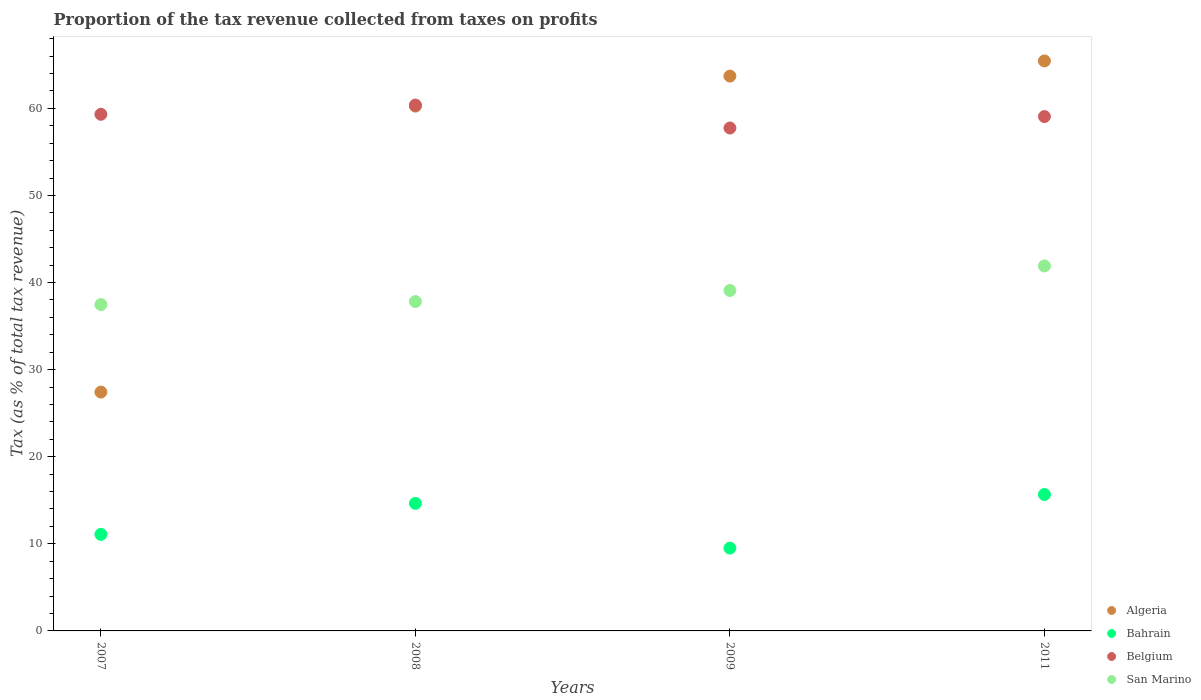How many different coloured dotlines are there?
Provide a short and direct response. 4. What is the proportion of the tax revenue collected in San Marino in 2008?
Offer a very short reply. 37.82. Across all years, what is the maximum proportion of the tax revenue collected in Algeria?
Offer a terse response. 65.45. Across all years, what is the minimum proportion of the tax revenue collected in San Marino?
Give a very brief answer. 37.47. In which year was the proportion of the tax revenue collected in Algeria maximum?
Give a very brief answer. 2011. What is the total proportion of the tax revenue collected in Bahrain in the graph?
Your answer should be very brief. 50.9. What is the difference between the proportion of the tax revenue collected in Belgium in 2008 and that in 2009?
Offer a very short reply. 2.63. What is the difference between the proportion of the tax revenue collected in San Marino in 2008 and the proportion of the tax revenue collected in Belgium in 2007?
Make the answer very short. -21.5. What is the average proportion of the tax revenue collected in Algeria per year?
Provide a short and direct response. 54.21. In the year 2008, what is the difference between the proportion of the tax revenue collected in San Marino and proportion of the tax revenue collected in Belgium?
Offer a terse response. -22.56. What is the ratio of the proportion of the tax revenue collected in Algeria in 2009 to that in 2011?
Provide a succinct answer. 0.97. What is the difference between the highest and the second highest proportion of the tax revenue collected in San Marino?
Give a very brief answer. 2.82. What is the difference between the highest and the lowest proportion of the tax revenue collected in Bahrain?
Provide a succinct answer. 6.15. Is the sum of the proportion of the tax revenue collected in Algeria in 2007 and 2009 greater than the maximum proportion of the tax revenue collected in Belgium across all years?
Provide a succinct answer. Yes. Is it the case that in every year, the sum of the proportion of the tax revenue collected in Belgium and proportion of the tax revenue collected in San Marino  is greater than the sum of proportion of the tax revenue collected in Bahrain and proportion of the tax revenue collected in Algeria?
Provide a succinct answer. No. Does the proportion of the tax revenue collected in Belgium monotonically increase over the years?
Provide a short and direct response. No. Is the proportion of the tax revenue collected in San Marino strictly greater than the proportion of the tax revenue collected in Bahrain over the years?
Ensure brevity in your answer.  Yes. Is the proportion of the tax revenue collected in Bahrain strictly less than the proportion of the tax revenue collected in Belgium over the years?
Your answer should be very brief. Yes. How many dotlines are there?
Keep it short and to the point. 4. How many years are there in the graph?
Give a very brief answer. 4. What is the difference between two consecutive major ticks on the Y-axis?
Ensure brevity in your answer.  10. Where does the legend appear in the graph?
Your answer should be very brief. Bottom right. How are the legend labels stacked?
Ensure brevity in your answer.  Vertical. What is the title of the graph?
Offer a terse response. Proportion of the tax revenue collected from taxes on profits. Does "Nicaragua" appear as one of the legend labels in the graph?
Offer a very short reply. No. What is the label or title of the X-axis?
Your answer should be very brief. Years. What is the label or title of the Y-axis?
Your response must be concise. Tax (as % of total tax revenue). What is the Tax (as % of total tax revenue) of Algeria in 2007?
Your answer should be compact. 27.42. What is the Tax (as % of total tax revenue) in Bahrain in 2007?
Your response must be concise. 11.08. What is the Tax (as % of total tax revenue) of Belgium in 2007?
Keep it short and to the point. 59.32. What is the Tax (as % of total tax revenue) of San Marino in 2007?
Make the answer very short. 37.47. What is the Tax (as % of total tax revenue) in Algeria in 2008?
Give a very brief answer. 60.26. What is the Tax (as % of total tax revenue) of Bahrain in 2008?
Ensure brevity in your answer.  14.65. What is the Tax (as % of total tax revenue) in Belgium in 2008?
Your response must be concise. 60.38. What is the Tax (as % of total tax revenue) of San Marino in 2008?
Make the answer very short. 37.82. What is the Tax (as % of total tax revenue) of Algeria in 2009?
Ensure brevity in your answer.  63.71. What is the Tax (as % of total tax revenue) of Bahrain in 2009?
Your answer should be very brief. 9.51. What is the Tax (as % of total tax revenue) of Belgium in 2009?
Your answer should be very brief. 57.75. What is the Tax (as % of total tax revenue) of San Marino in 2009?
Give a very brief answer. 39.09. What is the Tax (as % of total tax revenue) in Algeria in 2011?
Provide a succinct answer. 65.45. What is the Tax (as % of total tax revenue) in Bahrain in 2011?
Your answer should be compact. 15.66. What is the Tax (as % of total tax revenue) in Belgium in 2011?
Ensure brevity in your answer.  59.06. What is the Tax (as % of total tax revenue) of San Marino in 2011?
Your answer should be compact. 41.91. Across all years, what is the maximum Tax (as % of total tax revenue) in Algeria?
Provide a succinct answer. 65.45. Across all years, what is the maximum Tax (as % of total tax revenue) in Bahrain?
Your answer should be compact. 15.66. Across all years, what is the maximum Tax (as % of total tax revenue) of Belgium?
Your answer should be very brief. 60.38. Across all years, what is the maximum Tax (as % of total tax revenue) of San Marino?
Give a very brief answer. 41.91. Across all years, what is the minimum Tax (as % of total tax revenue) in Algeria?
Your answer should be compact. 27.42. Across all years, what is the minimum Tax (as % of total tax revenue) of Bahrain?
Provide a short and direct response. 9.51. Across all years, what is the minimum Tax (as % of total tax revenue) in Belgium?
Ensure brevity in your answer.  57.75. Across all years, what is the minimum Tax (as % of total tax revenue) in San Marino?
Offer a very short reply. 37.47. What is the total Tax (as % of total tax revenue) of Algeria in the graph?
Offer a terse response. 216.83. What is the total Tax (as % of total tax revenue) of Bahrain in the graph?
Provide a succinct answer. 50.9. What is the total Tax (as % of total tax revenue) in Belgium in the graph?
Offer a very short reply. 236.51. What is the total Tax (as % of total tax revenue) in San Marino in the graph?
Give a very brief answer. 156.29. What is the difference between the Tax (as % of total tax revenue) of Algeria in 2007 and that in 2008?
Keep it short and to the point. -32.84. What is the difference between the Tax (as % of total tax revenue) of Bahrain in 2007 and that in 2008?
Offer a terse response. -3.56. What is the difference between the Tax (as % of total tax revenue) in Belgium in 2007 and that in 2008?
Keep it short and to the point. -1.06. What is the difference between the Tax (as % of total tax revenue) in San Marino in 2007 and that in 2008?
Your response must be concise. -0.35. What is the difference between the Tax (as % of total tax revenue) in Algeria in 2007 and that in 2009?
Offer a terse response. -36.28. What is the difference between the Tax (as % of total tax revenue) in Bahrain in 2007 and that in 2009?
Keep it short and to the point. 1.57. What is the difference between the Tax (as % of total tax revenue) in Belgium in 2007 and that in 2009?
Make the answer very short. 1.57. What is the difference between the Tax (as % of total tax revenue) in San Marino in 2007 and that in 2009?
Your answer should be very brief. -1.62. What is the difference between the Tax (as % of total tax revenue) in Algeria in 2007 and that in 2011?
Your answer should be very brief. -38.02. What is the difference between the Tax (as % of total tax revenue) in Bahrain in 2007 and that in 2011?
Provide a short and direct response. -4.58. What is the difference between the Tax (as % of total tax revenue) of Belgium in 2007 and that in 2011?
Ensure brevity in your answer.  0.26. What is the difference between the Tax (as % of total tax revenue) of San Marino in 2007 and that in 2011?
Offer a very short reply. -4.43. What is the difference between the Tax (as % of total tax revenue) in Algeria in 2008 and that in 2009?
Your answer should be compact. -3.45. What is the difference between the Tax (as % of total tax revenue) of Bahrain in 2008 and that in 2009?
Ensure brevity in your answer.  5.14. What is the difference between the Tax (as % of total tax revenue) in Belgium in 2008 and that in 2009?
Your answer should be compact. 2.63. What is the difference between the Tax (as % of total tax revenue) in San Marino in 2008 and that in 2009?
Make the answer very short. -1.27. What is the difference between the Tax (as % of total tax revenue) of Algeria in 2008 and that in 2011?
Ensure brevity in your answer.  -5.19. What is the difference between the Tax (as % of total tax revenue) in Bahrain in 2008 and that in 2011?
Make the answer very short. -1.01. What is the difference between the Tax (as % of total tax revenue) in Belgium in 2008 and that in 2011?
Offer a very short reply. 1.32. What is the difference between the Tax (as % of total tax revenue) of San Marino in 2008 and that in 2011?
Keep it short and to the point. -4.09. What is the difference between the Tax (as % of total tax revenue) of Algeria in 2009 and that in 2011?
Provide a succinct answer. -1.74. What is the difference between the Tax (as % of total tax revenue) of Bahrain in 2009 and that in 2011?
Keep it short and to the point. -6.15. What is the difference between the Tax (as % of total tax revenue) of Belgium in 2009 and that in 2011?
Your answer should be very brief. -1.32. What is the difference between the Tax (as % of total tax revenue) of San Marino in 2009 and that in 2011?
Give a very brief answer. -2.82. What is the difference between the Tax (as % of total tax revenue) in Algeria in 2007 and the Tax (as % of total tax revenue) in Bahrain in 2008?
Make the answer very short. 12.77. What is the difference between the Tax (as % of total tax revenue) in Algeria in 2007 and the Tax (as % of total tax revenue) in Belgium in 2008?
Ensure brevity in your answer.  -32.96. What is the difference between the Tax (as % of total tax revenue) in Algeria in 2007 and the Tax (as % of total tax revenue) in San Marino in 2008?
Provide a short and direct response. -10.4. What is the difference between the Tax (as % of total tax revenue) in Bahrain in 2007 and the Tax (as % of total tax revenue) in Belgium in 2008?
Provide a short and direct response. -49.29. What is the difference between the Tax (as % of total tax revenue) in Bahrain in 2007 and the Tax (as % of total tax revenue) in San Marino in 2008?
Give a very brief answer. -26.74. What is the difference between the Tax (as % of total tax revenue) in Belgium in 2007 and the Tax (as % of total tax revenue) in San Marino in 2008?
Ensure brevity in your answer.  21.5. What is the difference between the Tax (as % of total tax revenue) of Algeria in 2007 and the Tax (as % of total tax revenue) of Bahrain in 2009?
Offer a very short reply. 17.91. What is the difference between the Tax (as % of total tax revenue) of Algeria in 2007 and the Tax (as % of total tax revenue) of Belgium in 2009?
Provide a short and direct response. -30.32. What is the difference between the Tax (as % of total tax revenue) in Algeria in 2007 and the Tax (as % of total tax revenue) in San Marino in 2009?
Provide a short and direct response. -11.67. What is the difference between the Tax (as % of total tax revenue) of Bahrain in 2007 and the Tax (as % of total tax revenue) of Belgium in 2009?
Your answer should be very brief. -46.66. What is the difference between the Tax (as % of total tax revenue) in Bahrain in 2007 and the Tax (as % of total tax revenue) in San Marino in 2009?
Provide a short and direct response. -28.01. What is the difference between the Tax (as % of total tax revenue) in Belgium in 2007 and the Tax (as % of total tax revenue) in San Marino in 2009?
Your response must be concise. 20.23. What is the difference between the Tax (as % of total tax revenue) of Algeria in 2007 and the Tax (as % of total tax revenue) of Bahrain in 2011?
Offer a very short reply. 11.76. What is the difference between the Tax (as % of total tax revenue) in Algeria in 2007 and the Tax (as % of total tax revenue) in Belgium in 2011?
Offer a terse response. -31.64. What is the difference between the Tax (as % of total tax revenue) of Algeria in 2007 and the Tax (as % of total tax revenue) of San Marino in 2011?
Give a very brief answer. -14.48. What is the difference between the Tax (as % of total tax revenue) of Bahrain in 2007 and the Tax (as % of total tax revenue) of Belgium in 2011?
Your response must be concise. -47.98. What is the difference between the Tax (as % of total tax revenue) in Bahrain in 2007 and the Tax (as % of total tax revenue) in San Marino in 2011?
Offer a very short reply. -30.82. What is the difference between the Tax (as % of total tax revenue) in Belgium in 2007 and the Tax (as % of total tax revenue) in San Marino in 2011?
Keep it short and to the point. 17.41. What is the difference between the Tax (as % of total tax revenue) in Algeria in 2008 and the Tax (as % of total tax revenue) in Bahrain in 2009?
Offer a terse response. 50.75. What is the difference between the Tax (as % of total tax revenue) in Algeria in 2008 and the Tax (as % of total tax revenue) in Belgium in 2009?
Your answer should be compact. 2.51. What is the difference between the Tax (as % of total tax revenue) in Algeria in 2008 and the Tax (as % of total tax revenue) in San Marino in 2009?
Your response must be concise. 21.17. What is the difference between the Tax (as % of total tax revenue) of Bahrain in 2008 and the Tax (as % of total tax revenue) of Belgium in 2009?
Offer a terse response. -43.1. What is the difference between the Tax (as % of total tax revenue) of Bahrain in 2008 and the Tax (as % of total tax revenue) of San Marino in 2009?
Your response must be concise. -24.44. What is the difference between the Tax (as % of total tax revenue) of Belgium in 2008 and the Tax (as % of total tax revenue) of San Marino in 2009?
Ensure brevity in your answer.  21.29. What is the difference between the Tax (as % of total tax revenue) of Algeria in 2008 and the Tax (as % of total tax revenue) of Bahrain in 2011?
Ensure brevity in your answer.  44.6. What is the difference between the Tax (as % of total tax revenue) of Algeria in 2008 and the Tax (as % of total tax revenue) of Belgium in 2011?
Keep it short and to the point. 1.2. What is the difference between the Tax (as % of total tax revenue) of Algeria in 2008 and the Tax (as % of total tax revenue) of San Marino in 2011?
Your answer should be compact. 18.35. What is the difference between the Tax (as % of total tax revenue) of Bahrain in 2008 and the Tax (as % of total tax revenue) of Belgium in 2011?
Provide a short and direct response. -44.41. What is the difference between the Tax (as % of total tax revenue) in Bahrain in 2008 and the Tax (as % of total tax revenue) in San Marino in 2011?
Give a very brief answer. -27.26. What is the difference between the Tax (as % of total tax revenue) of Belgium in 2008 and the Tax (as % of total tax revenue) of San Marino in 2011?
Give a very brief answer. 18.47. What is the difference between the Tax (as % of total tax revenue) of Algeria in 2009 and the Tax (as % of total tax revenue) of Bahrain in 2011?
Your answer should be very brief. 48.04. What is the difference between the Tax (as % of total tax revenue) of Algeria in 2009 and the Tax (as % of total tax revenue) of Belgium in 2011?
Offer a terse response. 4.64. What is the difference between the Tax (as % of total tax revenue) of Algeria in 2009 and the Tax (as % of total tax revenue) of San Marino in 2011?
Your answer should be very brief. 21.8. What is the difference between the Tax (as % of total tax revenue) in Bahrain in 2009 and the Tax (as % of total tax revenue) in Belgium in 2011?
Your response must be concise. -49.55. What is the difference between the Tax (as % of total tax revenue) in Bahrain in 2009 and the Tax (as % of total tax revenue) in San Marino in 2011?
Your response must be concise. -32.4. What is the difference between the Tax (as % of total tax revenue) of Belgium in 2009 and the Tax (as % of total tax revenue) of San Marino in 2011?
Provide a succinct answer. 15.84. What is the average Tax (as % of total tax revenue) of Algeria per year?
Keep it short and to the point. 54.21. What is the average Tax (as % of total tax revenue) of Bahrain per year?
Your answer should be compact. 12.73. What is the average Tax (as % of total tax revenue) in Belgium per year?
Provide a short and direct response. 59.13. What is the average Tax (as % of total tax revenue) in San Marino per year?
Your answer should be very brief. 39.07. In the year 2007, what is the difference between the Tax (as % of total tax revenue) in Algeria and Tax (as % of total tax revenue) in Bahrain?
Offer a terse response. 16.34. In the year 2007, what is the difference between the Tax (as % of total tax revenue) in Algeria and Tax (as % of total tax revenue) in Belgium?
Your response must be concise. -31.9. In the year 2007, what is the difference between the Tax (as % of total tax revenue) of Algeria and Tax (as % of total tax revenue) of San Marino?
Provide a short and direct response. -10.05. In the year 2007, what is the difference between the Tax (as % of total tax revenue) of Bahrain and Tax (as % of total tax revenue) of Belgium?
Offer a very short reply. -48.24. In the year 2007, what is the difference between the Tax (as % of total tax revenue) of Bahrain and Tax (as % of total tax revenue) of San Marino?
Ensure brevity in your answer.  -26.39. In the year 2007, what is the difference between the Tax (as % of total tax revenue) of Belgium and Tax (as % of total tax revenue) of San Marino?
Ensure brevity in your answer.  21.85. In the year 2008, what is the difference between the Tax (as % of total tax revenue) in Algeria and Tax (as % of total tax revenue) in Bahrain?
Give a very brief answer. 45.61. In the year 2008, what is the difference between the Tax (as % of total tax revenue) in Algeria and Tax (as % of total tax revenue) in Belgium?
Offer a very short reply. -0.12. In the year 2008, what is the difference between the Tax (as % of total tax revenue) in Algeria and Tax (as % of total tax revenue) in San Marino?
Keep it short and to the point. 22.44. In the year 2008, what is the difference between the Tax (as % of total tax revenue) of Bahrain and Tax (as % of total tax revenue) of Belgium?
Your response must be concise. -45.73. In the year 2008, what is the difference between the Tax (as % of total tax revenue) in Bahrain and Tax (as % of total tax revenue) in San Marino?
Make the answer very short. -23.17. In the year 2008, what is the difference between the Tax (as % of total tax revenue) of Belgium and Tax (as % of total tax revenue) of San Marino?
Offer a terse response. 22.56. In the year 2009, what is the difference between the Tax (as % of total tax revenue) of Algeria and Tax (as % of total tax revenue) of Bahrain?
Offer a very short reply. 54.2. In the year 2009, what is the difference between the Tax (as % of total tax revenue) of Algeria and Tax (as % of total tax revenue) of Belgium?
Give a very brief answer. 5.96. In the year 2009, what is the difference between the Tax (as % of total tax revenue) of Algeria and Tax (as % of total tax revenue) of San Marino?
Make the answer very short. 24.62. In the year 2009, what is the difference between the Tax (as % of total tax revenue) of Bahrain and Tax (as % of total tax revenue) of Belgium?
Your answer should be very brief. -48.24. In the year 2009, what is the difference between the Tax (as % of total tax revenue) of Bahrain and Tax (as % of total tax revenue) of San Marino?
Provide a short and direct response. -29.58. In the year 2009, what is the difference between the Tax (as % of total tax revenue) of Belgium and Tax (as % of total tax revenue) of San Marino?
Ensure brevity in your answer.  18.66. In the year 2011, what is the difference between the Tax (as % of total tax revenue) in Algeria and Tax (as % of total tax revenue) in Bahrain?
Your answer should be compact. 49.78. In the year 2011, what is the difference between the Tax (as % of total tax revenue) of Algeria and Tax (as % of total tax revenue) of Belgium?
Make the answer very short. 6.39. In the year 2011, what is the difference between the Tax (as % of total tax revenue) of Algeria and Tax (as % of total tax revenue) of San Marino?
Your answer should be compact. 23.54. In the year 2011, what is the difference between the Tax (as % of total tax revenue) of Bahrain and Tax (as % of total tax revenue) of Belgium?
Your answer should be very brief. -43.4. In the year 2011, what is the difference between the Tax (as % of total tax revenue) in Bahrain and Tax (as % of total tax revenue) in San Marino?
Keep it short and to the point. -26.24. In the year 2011, what is the difference between the Tax (as % of total tax revenue) in Belgium and Tax (as % of total tax revenue) in San Marino?
Give a very brief answer. 17.15. What is the ratio of the Tax (as % of total tax revenue) of Algeria in 2007 to that in 2008?
Give a very brief answer. 0.46. What is the ratio of the Tax (as % of total tax revenue) in Bahrain in 2007 to that in 2008?
Provide a short and direct response. 0.76. What is the ratio of the Tax (as % of total tax revenue) of Belgium in 2007 to that in 2008?
Offer a terse response. 0.98. What is the ratio of the Tax (as % of total tax revenue) in Algeria in 2007 to that in 2009?
Offer a very short reply. 0.43. What is the ratio of the Tax (as % of total tax revenue) in Bahrain in 2007 to that in 2009?
Your answer should be very brief. 1.17. What is the ratio of the Tax (as % of total tax revenue) of Belgium in 2007 to that in 2009?
Provide a short and direct response. 1.03. What is the ratio of the Tax (as % of total tax revenue) of San Marino in 2007 to that in 2009?
Offer a terse response. 0.96. What is the ratio of the Tax (as % of total tax revenue) of Algeria in 2007 to that in 2011?
Ensure brevity in your answer.  0.42. What is the ratio of the Tax (as % of total tax revenue) of Bahrain in 2007 to that in 2011?
Offer a very short reply. 0.71. What is the ratio of the Tax (as % of total tax revenue) in San Marino in 2007 to that in 2011?
Offer a terse response. 0.89. What is the ratio of the Tax (as % of total tax revenue) in Algeria in 2008 to that in 2009?
Make the answer very short. 0.95. What is the ratio of the Tax (as % of total tax revenue) in Bahrain in 2008 to that in 2009?
Your response must be concise. 1.54. What is the ratio of the Tax (as % of total tax revenue) of Belgium in 2008 to that in 2009?
Offer a very short reply. 1.05. What is the ratio of the Tax (as % of total tax revenue) of San Marino in 2008 to that in 2009?
Provide a succinct answer. 0.97. What is the ratio of the Tax (as % of total tax revenue) in Algeria in 2008 to that in 2011?
Provide a succinct answer. 0.92. What is the ratio of the Tax (as % of total tax revenue) of Bahrain in 2008 to that in 2011?
Offer a very short reply. 0.94. What is the ratio of the Tax (as % of total tax revenue) in Belgium in 2008 to that in 2011?
Offer a terse response. 1.02. What is the ratio of the Tax (as % of total tax revenue) of San Marino in 2008 to that in 2011?
Offer a terse response. 0.9. What is the ratio of the Tax (as % of total tax revenue) in Algeria in 2009 to that in 2011?
Offer a terse response. 0.97. What is the ratio of the Tax (as % of total tax revenue) of Bahrain in 2009 to that in 2011?
Ensure brevity in your answer.  0.61. What is the ratio of the Tax (as % of total tax revenue) in Belgium in 2009 to that in 2011?
Offer a terse response. 0.98. What is the ratio of the Tax (as % of total tax revenue) of San Marino in 2009 to that in 2011?
Provide a succinct answer. 0.93. What is the difference between the highest and the second highest Tax (as % of total tax revenue) in Algeria?
Ensure brevity in your answer.  1.74. What is the difference between the highest and the second highest Tax (as % of total tax revenue) of Bahrain?
Provide a short and direct response. 1.01. What is the difference between the highest and the second highest Tax (as % of total tax revenue) of Belgium?
Offer a very short reply. 1.06. What is the difference between the highest and the second highest Tax (as % of total tax revenue) of San Marino?
Make the answer very short. 2.82. What is the difference between the highest and the lowest Tax (as % of total tax revenue) of Algeria?
Your response must be concise. 38.02. What is the difference between the highest and the lowest Tax (as % of total tax revenue) of Bahrain?
Keep it short and to the point. 6.15. What is the difference between the highest and the lowest Tax (as % of total tax revenue) in Belgium?
Your response must be concise. 2.63. What is the difference between the highest and the lowest Tax (as % of total tax revenue) of San Marino?
Your answer should be compact. 4.43. 